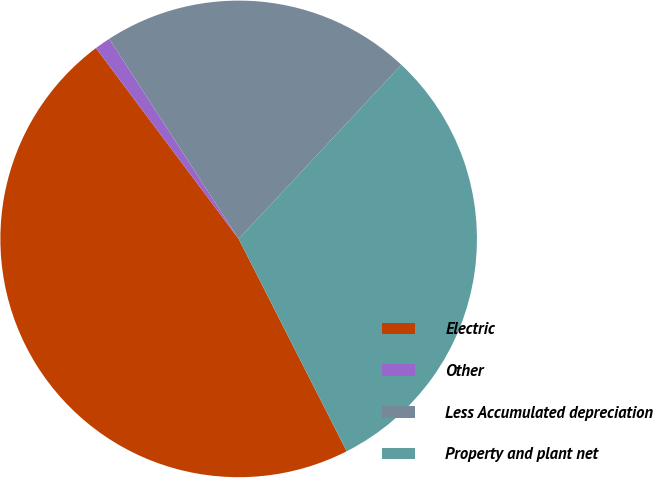<chart> <loc_0><loc_0><loc_500><loc_500><pie_chart><fcel>Electric<fcel>Other<fcel>Less Accumulated depreciation<fcel>Property and plant net<nl><fcel>47.27%<fcel>1.08%<fcel>21.1%<fcel>30.55%<nl></chart> 